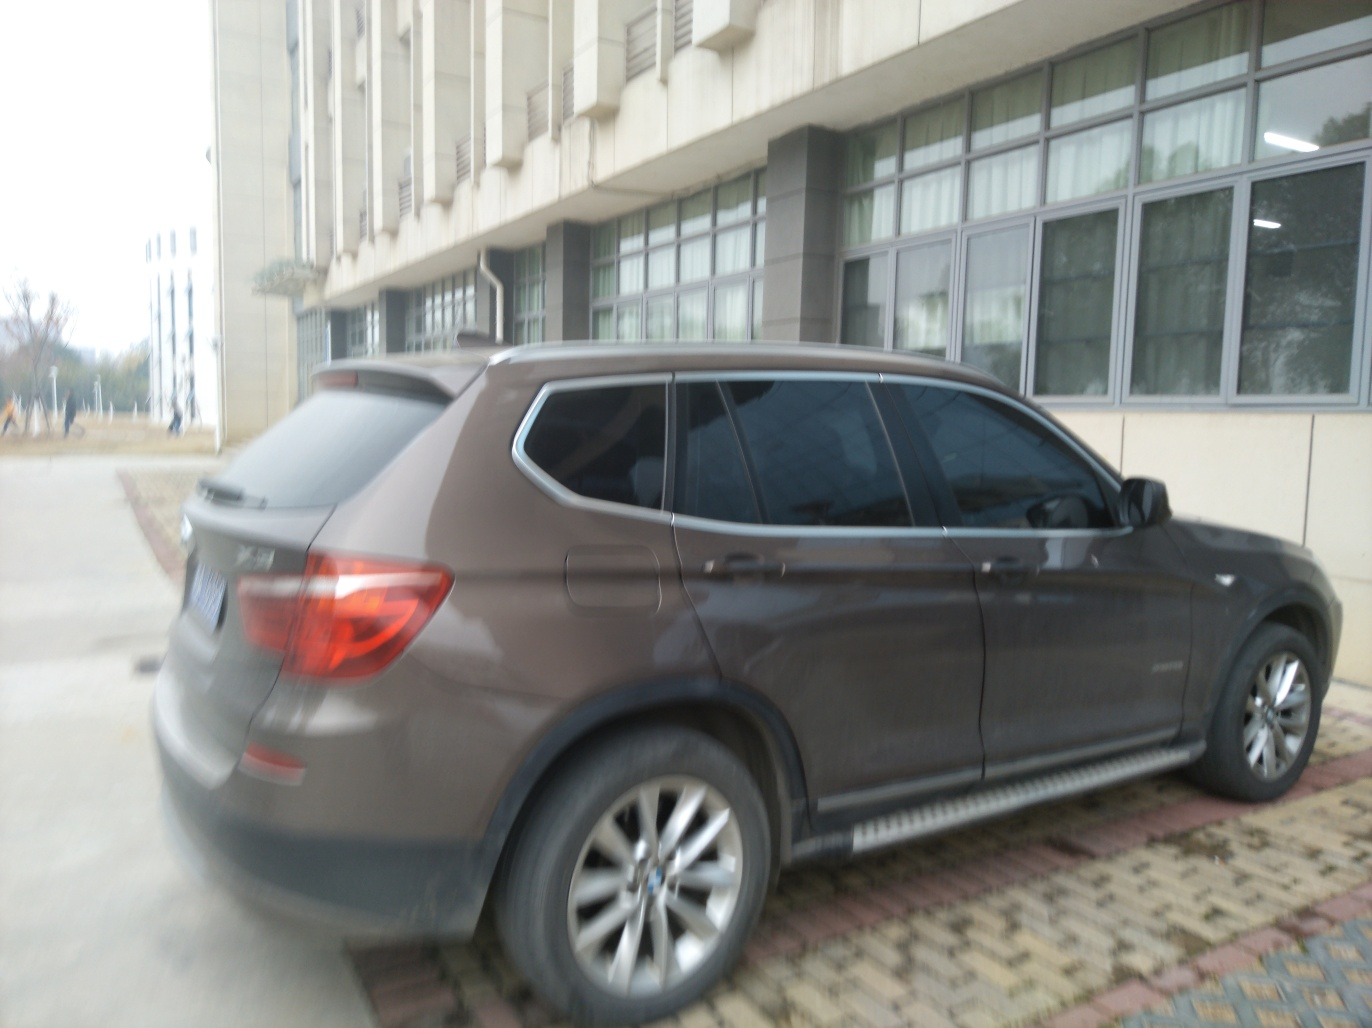Does the image have sufficient lighting? The image has moderate lighting, but it's not optimal. There is enough light to identify the main subject—a car parked outside a building—but the details are not crisp, and shadows obscure parts of the scene. It's sufficiently lit to give a general idea of the environment, yet falls short of providing a vibrant and clear image where finer details would be more discernible. 